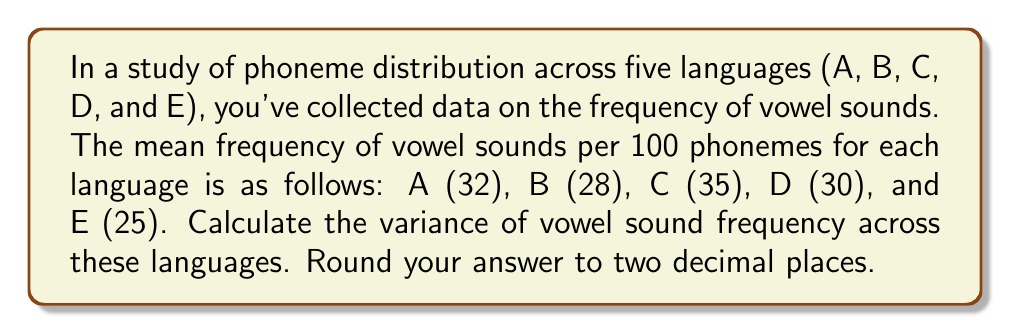Provide a solution to this math problem. To calculate the variance of vowel sound frequency across the languages, we'll follow these steps:

1. Calculate the mean of the frequencies:
   $$\bar{x} = \frac{32 + 28 + 35 + 30 + 25}{5} = 30$$

2. Calculate the squared deviations from the mean:
   Language A: $(32 - 30)^2 = 4$
   Language B: $(28 - 30)^2 = 4$
   Language C: $(35 - 30)^2 = 25$
   Language D: $(30 - 30)^2 = 0$
   Language E: $(25 - 30)^2 = 25$

3. Sum the squared deviations:
   $$\sum (x_i - \bar{x})^2 = 4 + 4 + 25 + 0 + 25 = 58$$

4. Divide by (n-1), where n is the number of languages:
   $$\text{Variance} = \frac{\sum (x_i - \bar{x})^2}{n-1} = \frac{58}{5-1} = \frac{58}{4} = 14.5$$

5. Round to two decimal places:
   14.50
Answer: 14.50 